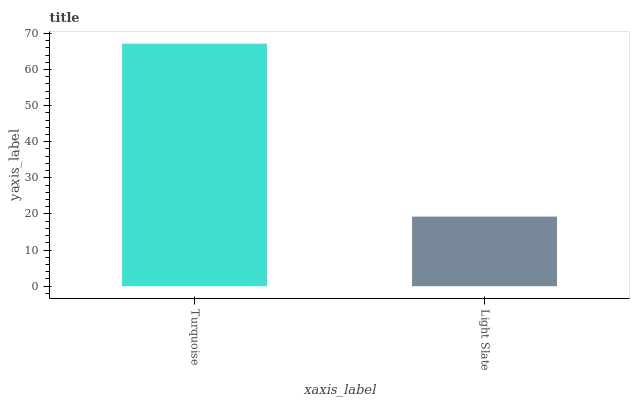Is Light Slate the minimum?
Answer yes or no. Yes. Is Turquoise the maximum?
Answer yes or no. Yes. Is Light Slate the maximum?
Answer yes or no. No. Is Turquoise greater than Light Slate?
Answer yes or no. Yes. Is Light Slate less than Turquoise?
Answer yes or no. Yes. Is Light Slate greater than Turquoise?
Answer yes or no. No. Is Turquoise less than Light Slate?
Answer yes or no. No. Is Turquoise the high median?
Answer yes or no. Yes. Is Light Slate the low median?
Answer yes or no. Yes. Is Light Slate the high median?
Answer yes or no. No. Is Turquoise the low median?
Answer yes or no. No. 